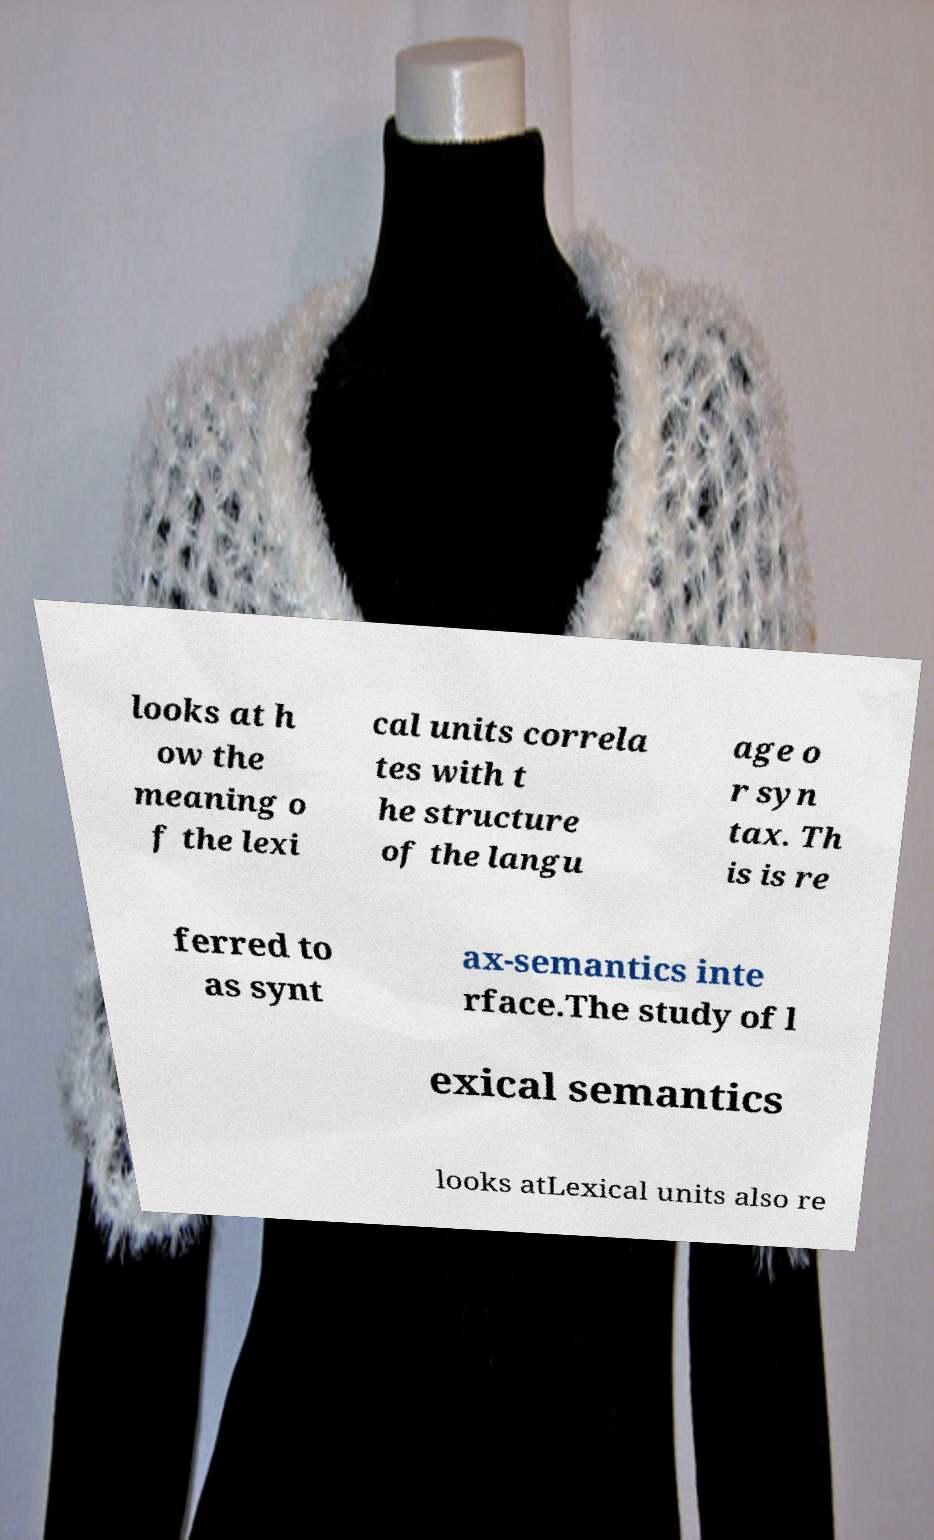Please read and relay the text visible in this image. What does it say? looks at h ow the meaning o f the lexi cal units correla tes with t he structure of the langu age o r syn tax. Th is is re ferred to as synt ax-semantics inte rface.The study of l exical semantics looks atLexical units also re 